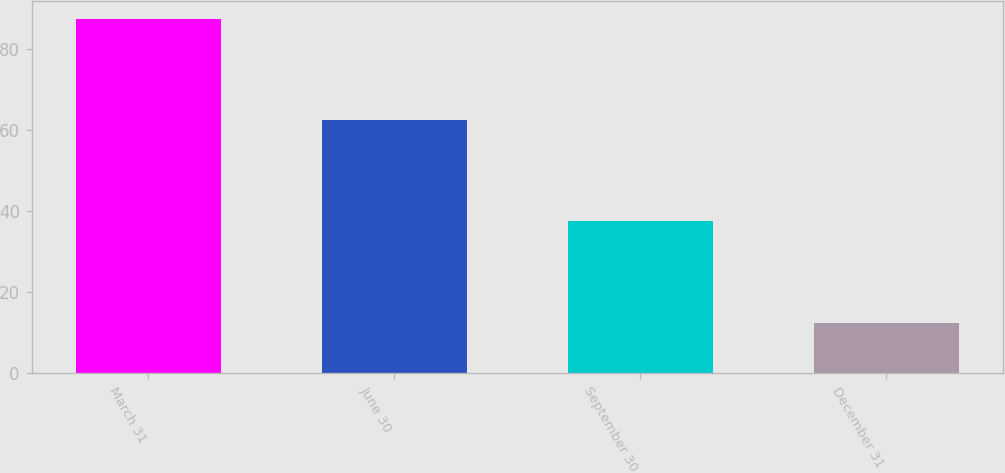Convert chart. <chart><loc_0><loc_0><loc_500><loc_500><bar_chart><fcel>March 31<fcel>June 30<fcel>September 30<fcel>December 31<nl><fcel>87.5<fcel>62.5<fcel>37.5<fcel>12.5<nl></chart> 